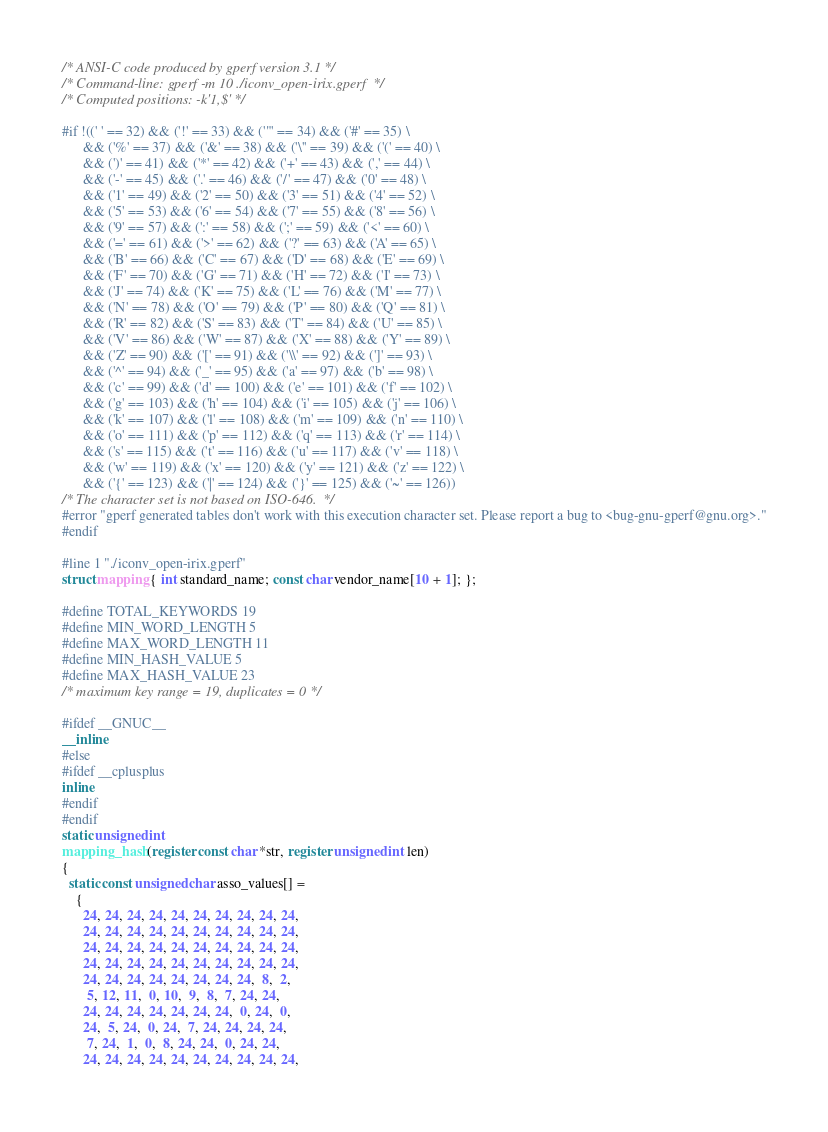<code> <loc_0><loc_0><loc_500><loc_500><_C_>/* ANSI-C code produced by gperf version 3.1 */
/* Command-line: gperf -m 10 ./iconv_open-irix.gperf  */
/* Computed positions: -k'1,$' */

#if !((' ' == 32) && ('!' == 33) && ('"' == 34) && ('#' == 35) \
      && ('%' == 37) && ('&' == 38) && ('\'' == 39) && ('(' == 40) \
      && (')' == 41) && ('*' == 42) && ('+' == 43) && (',' == 44) \
      && ('-' == 45) && ('.' == 46) && ('/' == 47) && ('0' == 48) \
      && ('1' == 49) && ('2' == 50) && ('3' == 51) && ('4' == 52) \
      && ('5' == 53) && ('6' == 54) && ('7' == 55) && ('8' == 56) \
      && ('9' == 57) && (':' == 58) && (';' == 59) && ('<' == 60) \
      && ('=' == 61) && ('>' == 62) && ('?' == 63) && ('A' == 65) \
      && ('B' == 66) && ('C' == 67) && ('D' == 68) && ('E' == 69) \
      && ('F' == 70) && ('G' == 71) && ('H' == 72) && ('I' == 73) \
      && ('J' == 74) && ('K' == 75) && ('L' == 76) && ('M' == 77) \
      && ('N' == 78) && ('O' == 79) && ('P' == 80) && ('Q' == 81) \
      && ('R' == 82) && ('S' == 83) && ('T' == 84) && ('U' == 85) \
      && ('V' == 86) && ('W' == 87) && ('X' == 88) && ('Y' == 89) \
      && ('Z' == 90) && ('[' == 91) && ('\\' == 92) && (']' == 93) \
      && ('^' == 94) && ('_' == 95) && ('a' == 97) && ('b' == 98) \
      && ('c' == 99) && ('d' == 100) && ('e' == 101) && ('f' == 102) \
      && ('g' == 103) && ('h' == 104) && ('i' == 105) && ('j' == 106) \
      && ('k' == 107) && ('l' == 108) && ('m' == 109) && ('n' == 110) \
      && ('o' == 111) && ('p' == 112) && ('q' == 113) && ('r' == 114) \
      && ('s' == 115) && ('t' == 116) && ('u' == 117) && ('v' == 118) \
      && ('w' == 119) && ('x' == 120) && ('y' == 121) && ('z' == 122) \
      && ('{' == 123) && ('|' == 124) && ('}' == 125) && ('~' == 126))
/* The character set is not based on ISO-646.  */
#error "gperf generated tables don't work with this execution character set. Please report a bug to <bug-gnu-gperf@gnu.org>."
#endif

#line 1 "./iconv_open-irix.gperf"
struct mapping { int standard_name; const char vendor_name[10 + 1]; };

#define TOTAL_KEYWORDS 19
#define MIN_WORD_LENGTH 5
#define MAX_WORD_LENGTH 11
#define MIN_HASH_VALUE 5
#define MAX_HASH_VALUE 23
/* maximum key range = 19, duplicates = 0 */

#ifdef __GNUC__
__inline
#else
#ifdef __cplusplus
inline
#endif
#endif
static unsigned int
mapping_hash (register const char *str, register unsigned int len)
{
  static const unsigned char asso_values[] =
    {
      24, 24, 24, 24, 24, 24, 24, 24, 24, 24,
      24, 24, 24, 24, 24, 24, 24, 24, 24, 24,
      24, 24, 24, 24, 24, 24, 24, 24, 24, 24,
      24, 24, 24, 24, 24, 24, 24, 24, 24, 24,
      24, 24, 24, 24, 24, 24, 24, 24,  8,  2,
       5, 12, 11,  0, 10,  9,  8,  7, 24, 24,
      24, 24, 24, 24, 24, 24, 24,  0, 24,  0,
      24,  5, 24,  0, 24,  7, 24, 24, 24, 24,
       7, 24,  1,  0,  8, 24, 24,  0, 24, 24,
      24, 24, 24, 24, 24, 24, 24, 24, 24, 24,</code> 